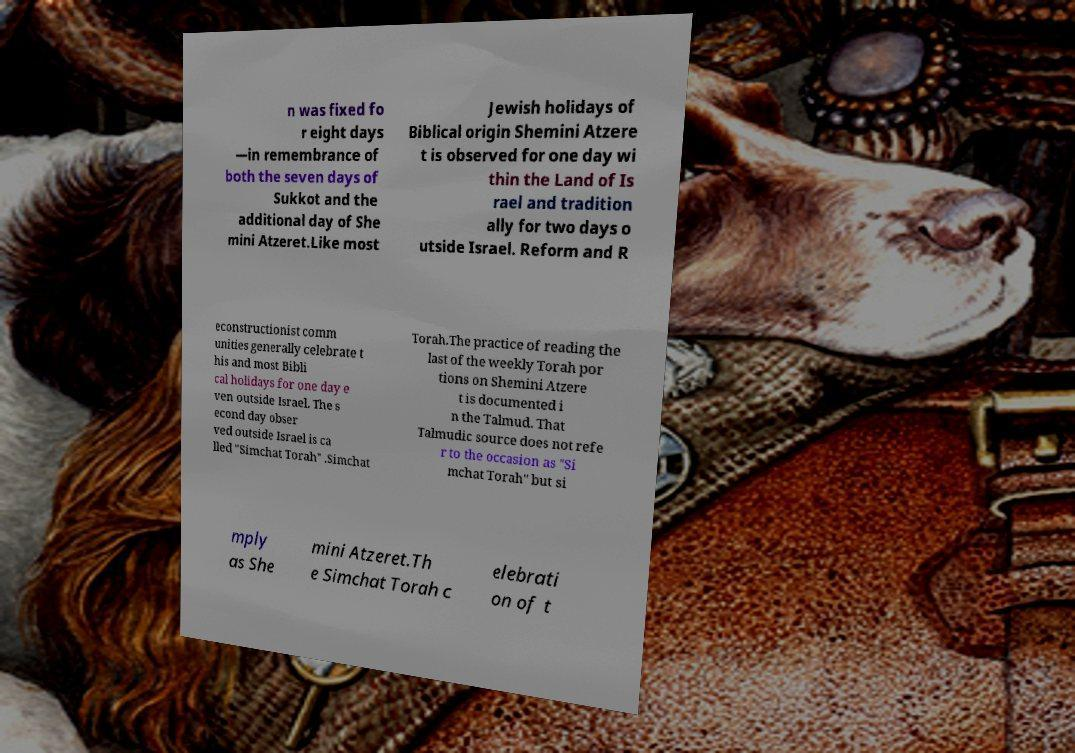Could you assist in decoding the text presented in this image and type it out clearly? n was fixed fo r eight days —in remembrance of both the seven days of Sukkot and the additional day of She mini Atzeret.Like most Jewish holidays of Biblical origin Shemini Atzere t is observed for one day wi thin the Land of Is rael and tradition ally for two days o utside Israel. Reform and R econstructionist comm unities generally celebrate t his and most Bibli cal holidays for one day e ven outside Israel. The s econd day obser ved outside Israel is ca lled "Simchat Torah" .Simchat Torah.The practice of reading the last of the weekly Torah por tions on Shemini Atzere t is documented i n the Talmud. That Talmudic source does not refe r to the occasion as "Si mchat Torah" but si mply as She mini Atzeret.Th e Simchat Torah c elebrati on of t 